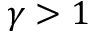<formula> <loc_0><loc_0><loc_500><loc_500>\gamma > 1</formula> 